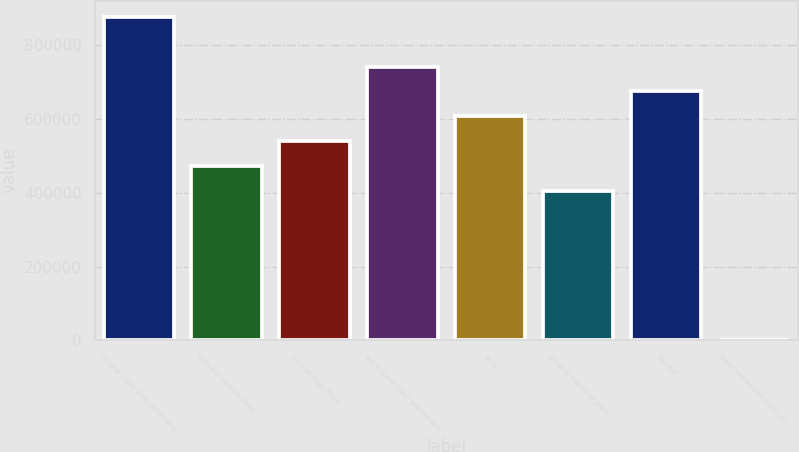Convert chart to OTSL. <chart><loc_0><loc_0><loc_500><loc_500><bar_chart><fcel>Income (loss) from continuing<fcel>Less Net income (loss)<fcel>Income (loss) from<fcel>Net income (loss) attributable<fcel>Basic<fcel>Dilutive impact of stock<fcel>Diluted<fcel>Basic net income (loss) per<nl><fcel>876026<fcel>471706<fcel>539093<fcel>741253<fcel>606479<fcel>404320<fcel>673866<fcel>0.08<nl></chart> 